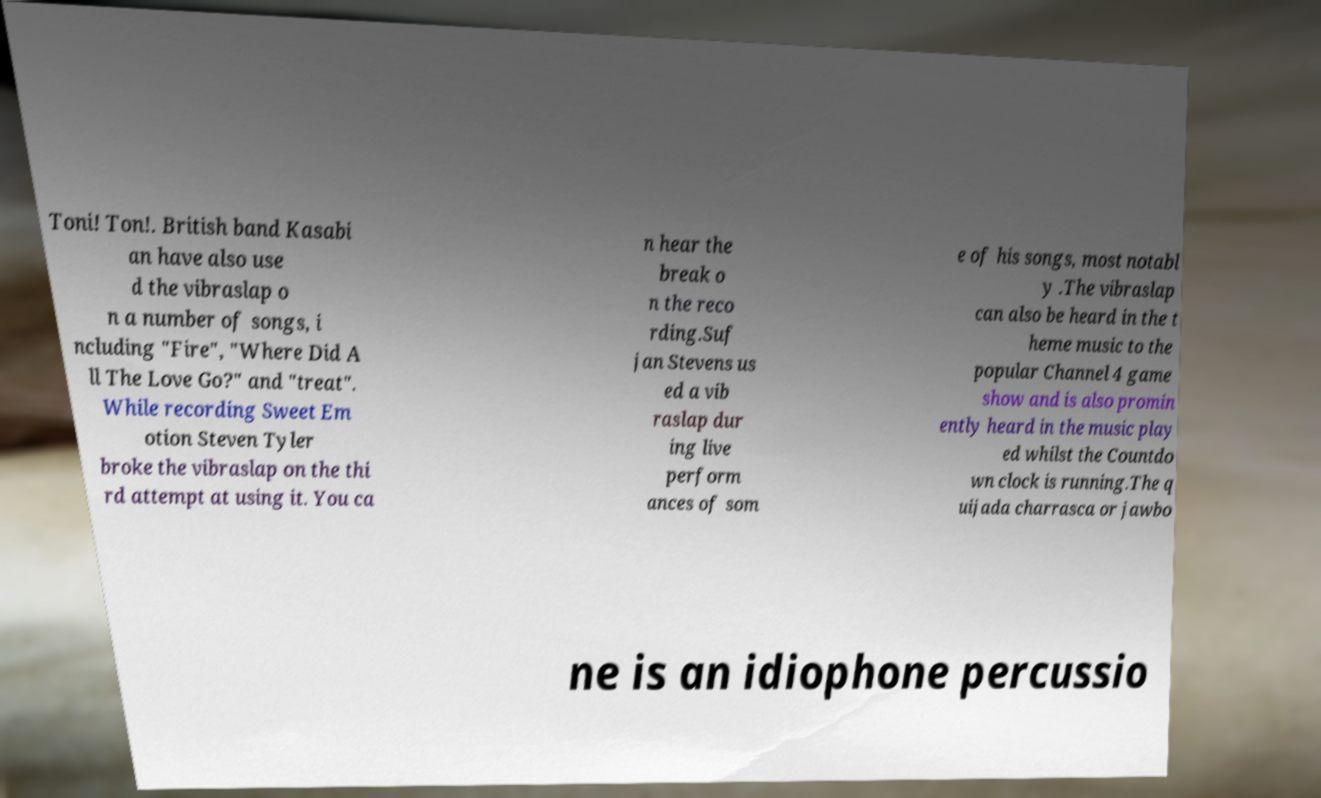I need the written content from this picture converted into text. Can you do that? Toni! Ton!. British band Kasabi an have also use d the vibraslap o n a number of songs, i ncluding "Fire", "Where Did A ll The Love Go?" and "treat". While recording Sweet Em otion Steven Tyler broke the vibraslap on the thi rd attempt at using it. You ca n hear the break o n the reco rding.Suf jan Stevens us ed a vib raslap dur ing live perform ances of som e of his songs, most notabl y .The vibraslap can also be heard in the t heme music to the popular Channel 4 game show and is also promin ently heard in the music play ed whilst the Countdo wn clock is running.The q uijada charrasca or jawbo ne is an idiophone percussio 